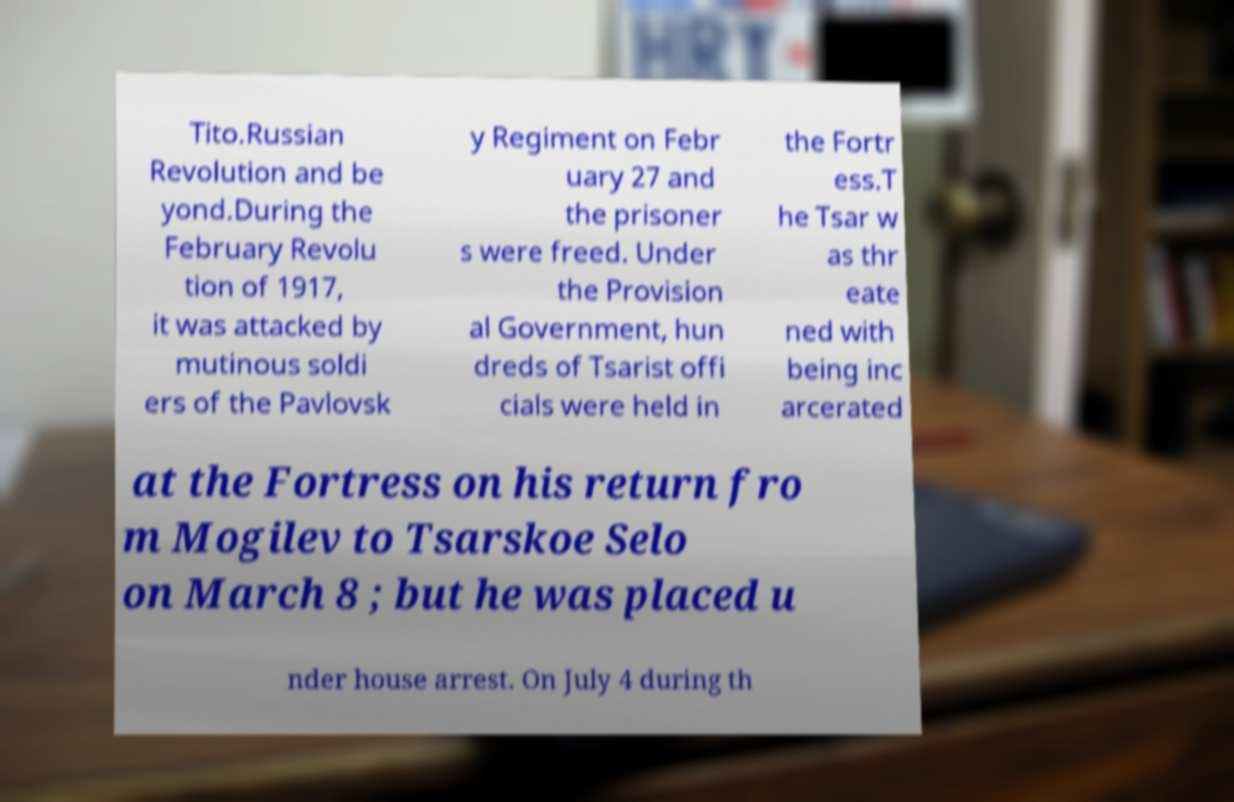Please identify and transcribe the text found in this image. Tito.Russian Revolution and be yond.During the February Revolu tion of 1917, it was attacked by mutinous soldi ers of the Pavlovsk y Regiment on Febr uary 27 and the prisoner s were freed. Under the Provision al Government, hun dreds of Tsarist offi cials were held in the Fortr ess.T he Tsar w as thr eate ned with being inc arcerated at the Fortress on his return fro m Mogilev to Tsarskoe Selo on March 8 ; but he was placed u nder house arrest. On July 4 during th 